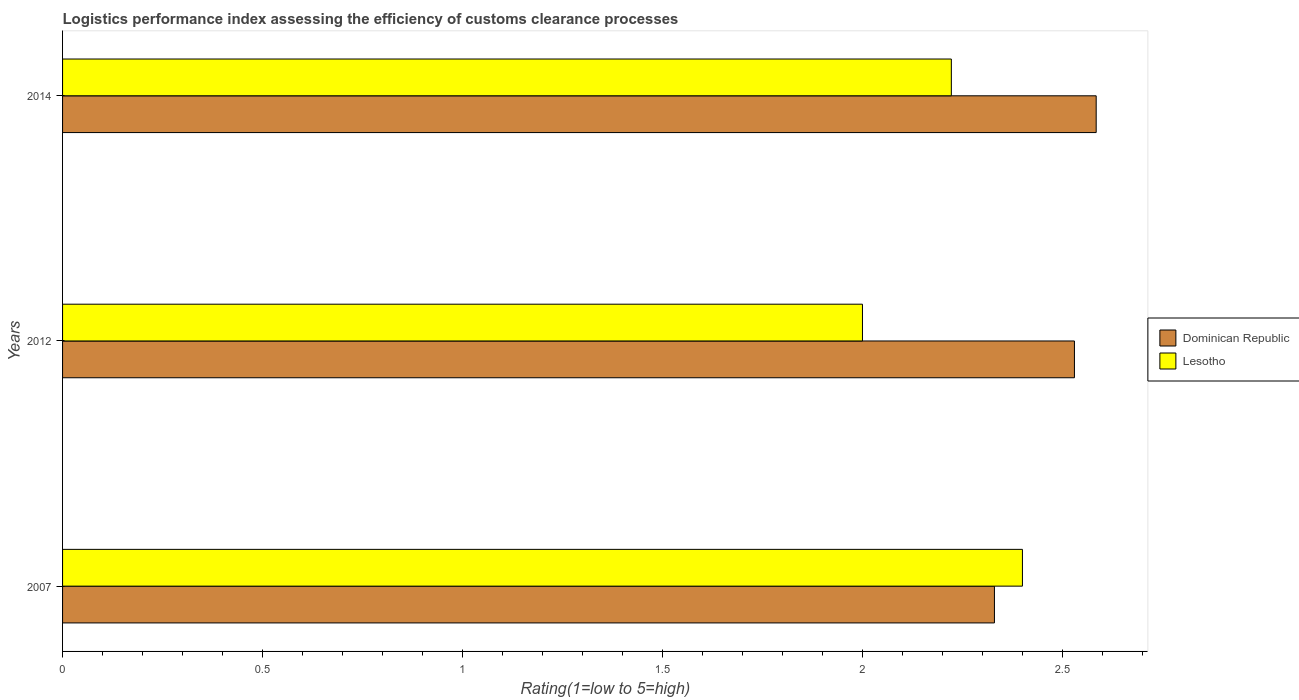Are the number of bars per tick equal to the number of legend labels?
Keep it short and to the point. Yes. Are the number of bars on each tick of the Y-axis equal?
Offer a terse response. Yes. How many bars are there on the 3rd tick from the top?
Provide a short and direct response. 2. In how many cases, is the number of bars for a given year not equal to the number of legend labels?
Offer a terse response. 0. What is the Logistic performance index in Dominican Republic in 2007?
Offer a very short reply. 2.33. Across all years, what is the maximum Logistic performance index in Dominican Republic?
Your answer should be compact. 2.58. Across all years, what is the minimum Logistic performance index in Dominican Republic?
Your response must be concise. 2.33. In which year was the Logistic performance index in Lesotho minimum?
Ensure brevity in your answer.  2012. What is the total Logistic performance index in Lesotho in the graph?
Your answer should be compact. 6.62. What is the difference between the Logistic performance index in Dominican Republic in 2007 and that in 2012?
Your answer should be very brief. -0.2. What is the difference between the Logistic performance index in Dominican Republic in 2014 and the Logistic performance index in Lesotho in 2007?
Make the answer very short. 0.18. What is the average Logistic performance index in Dominican Republic per year?
Make the answer very short. 2.48. In the year 2007, what is the difference between the Logistic performance index in Lesotho and Logistic performance index in Dominican Republic?
Offer a very short reply. 0.07. What is the ratio of the Logistic performance index in Dominican Republic in 2007 to that in 2014?
Your answer should be very brief. 0.9. Is the Logistic performance index in Lesotho in 2012 less than that in 2014?
Provide a succinct answer. Yes. Is the difference between the Logistic performance index in Lesotho in 2007 and 2014 greater than the difference between the Logistic performance index in Dominican Republic in 2007 and 2014?
Provide a short and direct response. Yes. What is the difference between the highest and the second highest Logistic performance index in Lesotho?
Keep it short and to the point. 0.18. What is the difference between the highest and the lowest Logistic performance index in Dominican Republic?
Your answer should be very brief. 0.25. Is the sum of the Logistic performance index in Lesotho in 2007 and 2014 greater than the maximum Logistic performance index in Dominican Republic across all years?
Provide a succinct answer. Yes. What does the 2nd bar from the top in 2014 represents?
Give a very brief answer. Dominican Republic. What does the 2nd bar from the bottom in 2012 represents?
Provide a short and direct response. Lesotho. How many bars are there?
Keep it short and to the point. 6. Are all the bars in the graph horizontal?
Provide a short and direct response. Yes. Where does the legend appear in the graph?
Your response must be concise. Center right. How many legend labels are there?
Your answer should be very brief. 2. What is the title of the graph?
Ensure brevity in your answer.  Logistics performance index assessing the efficiency of customs clearance processes. Does "Venezuela" appear as one of the legend labels in the graph?
Provide a short and direct response. No. What is the label or title of the X-axis?
Offer a very short reply. Rating(1=low to 5=high). What is the Rating(1=low to 5=high) of Dominican Republic in 2007?
Your response must be concise. 2.33. What is the Rating(1=low to 5=high) in Dominican Republic in 2012?
Your answer should be compact. 2.53. What is the Rating(1=low to 5=high) of Lesotho in 2012?
Make the answer very short. 2. What is the Rating(1=low to 5=high) in Dominican Republic in 2014?
Give a very brief answer. 2.58. What is the Rating(1=low to 5=high) in Lesotho in 2014?
Offer a very short reply. 2.22. Across all years, what is the maximum Rating(1=low to 5=high) in Dominican Republic?
Ensure brevity in your answer.  2.58. Across all years, what is the maximum Rating(1=low to 5=high) in Lesotho?
Ensure brevity in your answer.  2.4. Across all years, what is the minimum Rating(1=low to 5=high) of Dominican Republic?
Your answer should be compact. 2.33. What is the total Rating(1=low to 5=high) of Dominican Republic in the graph?
Offer a very short reply. 7.44. What is the total Rating(1=low to 5=high) in Lesotho in the graph?
Ensure brevity in your answer.  6.62. What is the difference between the Rating(1=low to 5=high) in Dominican Republic in 2007 and that in 2012?
Make the answer very short. -0.2. What is the difference between the Rating(1=low to 5=high) of Lesotho in 2007 and that in 2012?
Offer a very short reply. 0.4. What is the difference between the Rating(1=low to 5=high) of Dominican Republic in 2007 and that in 2014?
Offer a terse response. -0.25. What is the difference between the Rating(1=low to 5=high) of Lesotho in 2007 and that in 2014?
Your response must be concise. 0.18. What is the difference between the Rating(1=low to 5=high) of Dominican Republic in 2012 and that in 2014?
Offer a very short reply. -0.05. What is the difference between the Rating(1=low to 5=high) in Lesotho in 2012 and that in 2014?
Make the answer very short. -0.22. What is the difference between the Rating(1=low to 5=high) in Dominican Republic in 2007 and the Rating(1=low to 5=high) in Lesotho in 2012?
Your answer should be very brief. 0.33. What is the difference between the Rating(1=low to 5=high) of Dominican Republic in 2007 and the Rating(1=low to 5=high) of Lesotho in 2014?
Provide a succinct answer. 0.11. What is the difference between the Rating(1=low to 5=high) of Dominican Republic in 2012 and the Rating(1=low to 5=high) of Lesotho in 2014?
Your answer should be compact. 0.31. What is the average Rating(1=low to 5=high) of Dominican Republic per year?
Ensure brevity in your answer.  2.48. What is the average Rating(1=low to 5=high) in Lesotho per year?
Your answer should be compact. 2.21. In the year 2007, what is the difference between the Rating(1=low to 5=high) in Dominican Republic and Rating(1=low to 5=high) in Lesotho?
Provide a short and direct response. -0.07. In the year 2012, what is the difference between the Rating(1=low to 5=high) of Dominican Republic and Rating(1=low to 5=high) of Lesotho?
Provide a short and direct response. 0.53. In the year 2014, what is the difference between the Rating(1=low to 5=high) in Dominican Republic and Rating(1=low to 5=high) in Lesotho?
Give a very brief answer. 0.36. What is the ratio of the Rating(1=low to 5=high) in Dominican Republic in 2007 to that in 2012?
Ensure brevity in your answer.  0.92. What is the ratio of the Rating(1=low to 5=high) in Dominican Republic in 2007 to that in 2014?
Keep it short and to the point. 0.9. What is the ratio of the Rating(1=low to 5=high) of Lesotho in 2007 to that in 2014?
Your answer should be very brief. 1.08. What is the ratio of the Rating(1=low to 5=high) in Lesotho in 2012 to that in 2014?
Offer a very short reply. 0.9. What is the difference between the highest and the second highest Rating(1=low to 5=high) in Dominican Republic?
Your response must be concise. 0.05. What is the difference between the highest and the second highest Rating(1=low to 5=high) in Lesotho?
Give a very brief answer. 0.18. What is the difference between the highest and the lowest Rating(1=low to 5=high) in Dominican Republic?
Keep it short and to the point. 0.25. 